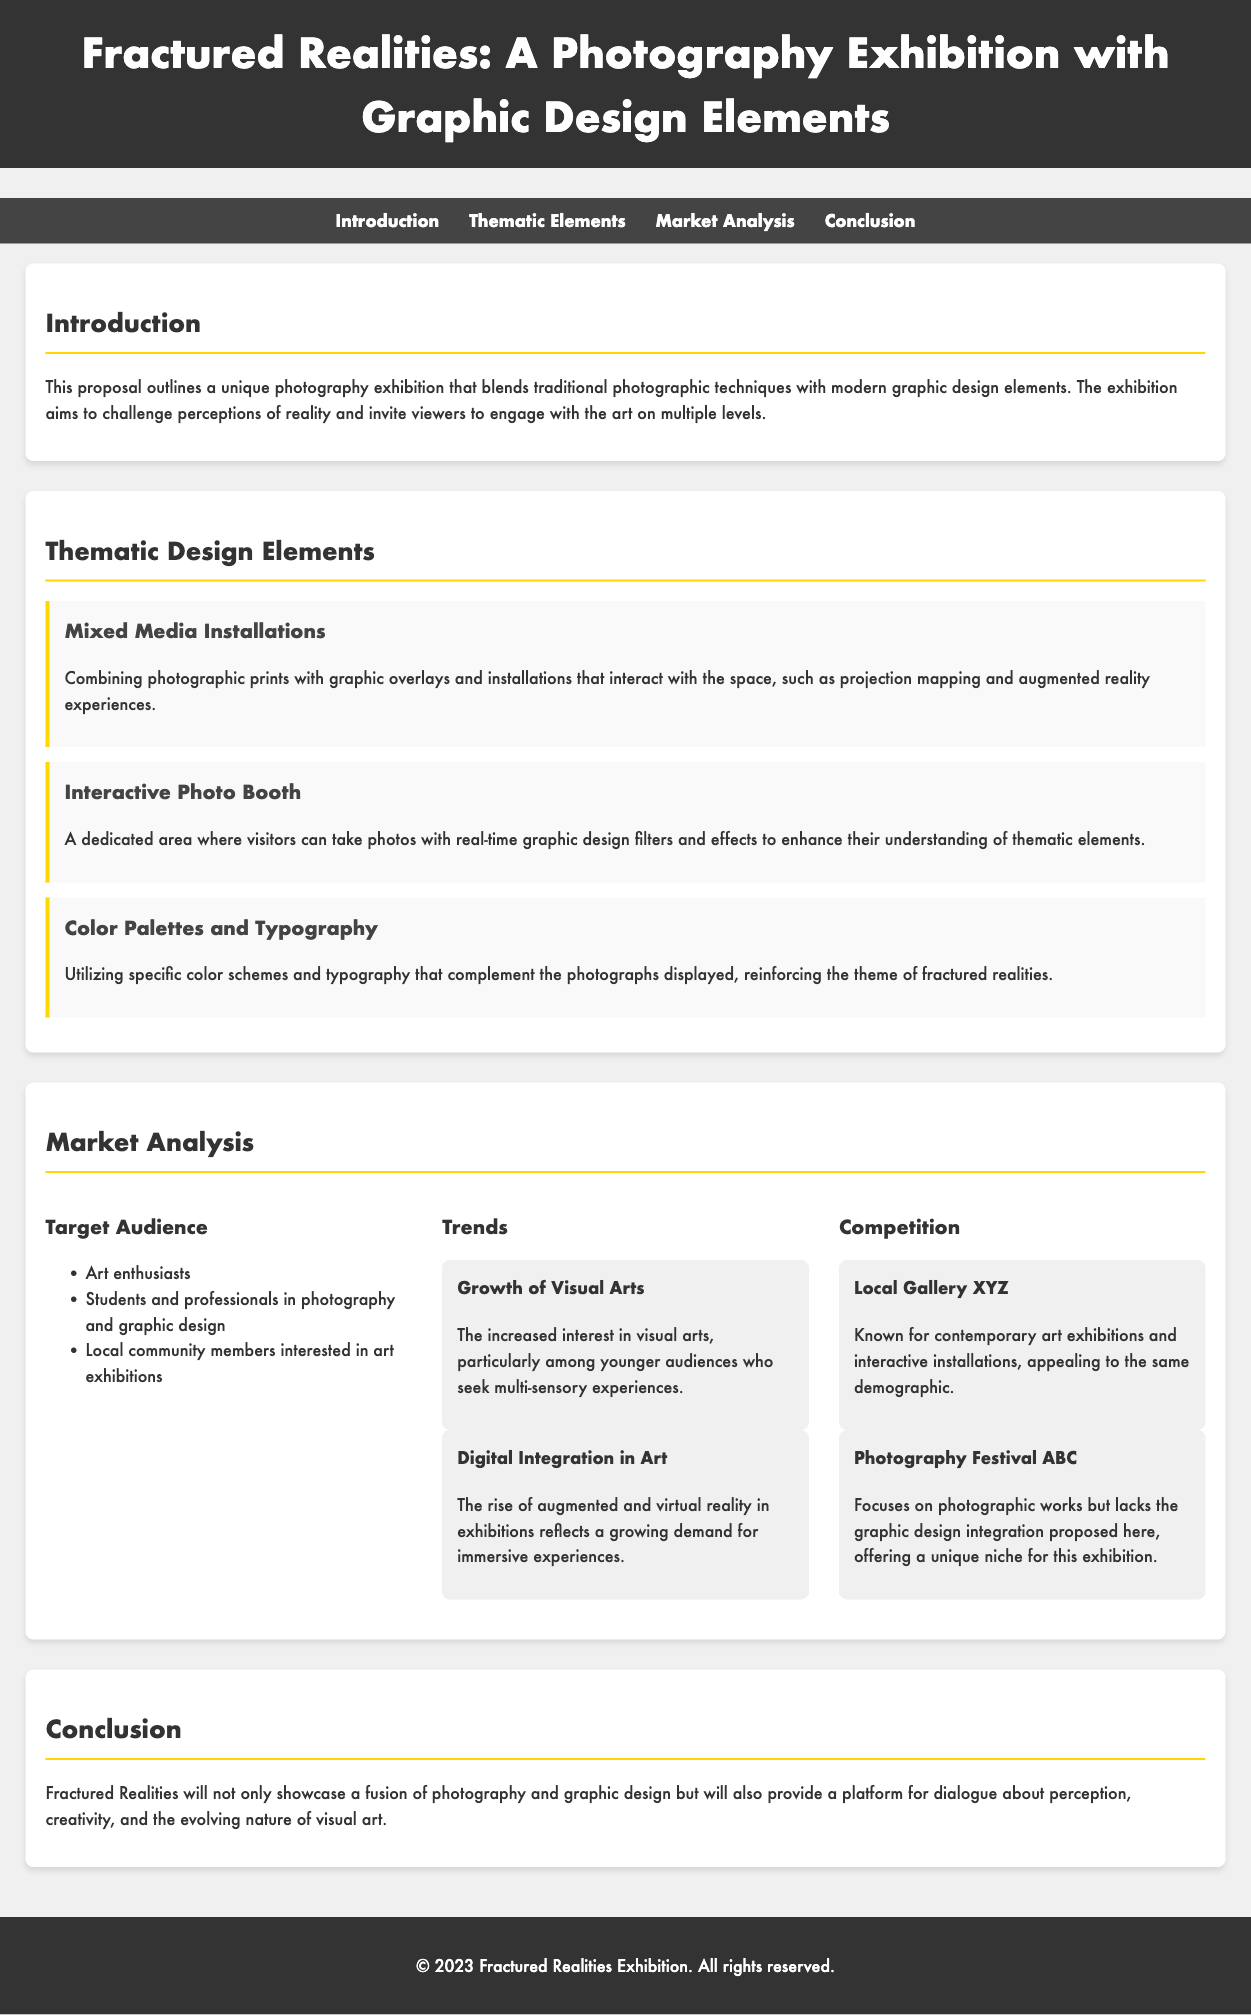what is the title of the exhibition? The title of the exhibition is prominently displayed at the top of the document.
Answer: Fractured Realities: A Photography Exhibition with Graphic Design Elements who is the target audience? The target audience is listed under the Market Analysis section in a bulleted format.
Answer: Art enthusiasts, Students and professionals in photography and graphic design, Local community members interested in art exhibitions what thematic design element involves interactive components? The thematic design elements include descriptions that outline various installations and interactive experiences.
Answer: Interactive Photo Booth how many trends are identified in the Market Analysis section? The Market Analysis section lists various trends affecting the exhibition, and the total is mentioned.
Answer: 2 which local gallery is mentioned as competition? The name of the local gallery is found in the competition subsection under Market Analysis.
Answer: Local Gallery XYZ what are the two main themes of the photography exhibition? The distinct themes of the exhibition can be inferred from the thematic elements section that describes mixed techniques.
Answer: photography and graphic design what aspect of modern technology is highlighted in the trends section? The trends section discusses various technological advancements that impact art.
Answer: Digital Integration in Art what visuals will be incorporated into the exhibition? The description of the thematic design elements suggests the kind of visuals being used.
Answer: Mixed Media Installations, Interactive Photo Booth, Color Palettes and Typography 